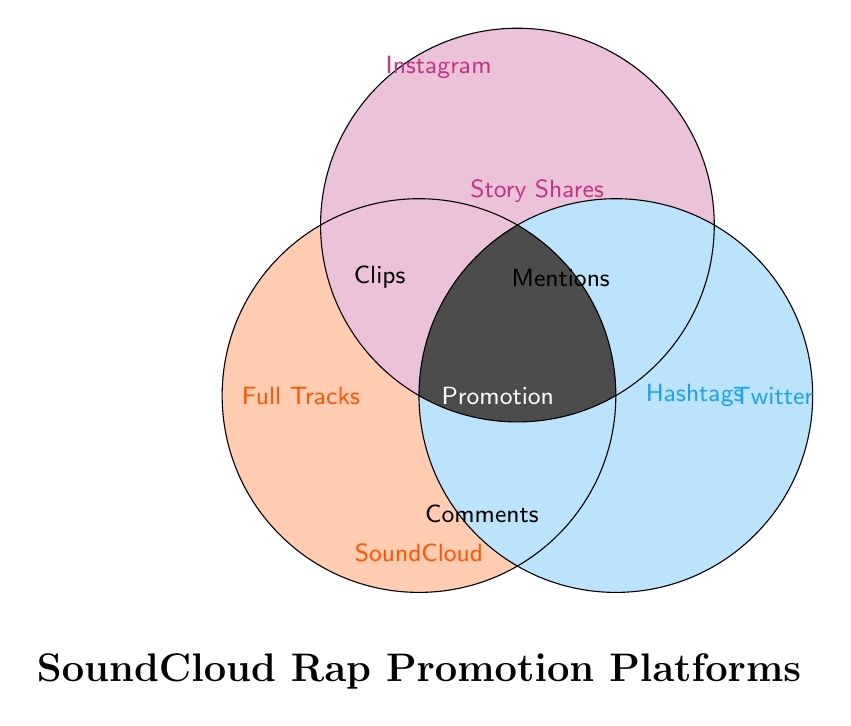What color represents SoundCloud? By looking at the Venn Diagram, the circle representing SoundCloud is filled with a distinct color. This color is closest to orange among the three used.
Answer: Orange Which platform is associated with Full Tracks? From the Venn Diagram, the text "Full Tracks" is located within the section labeled "SoundCloud." Therefore, SoundCloud is associated with Full Tracks.
Answer: SoundCloud Where do artists promote music using Story Shares? In the Venn Diagram, the term "Story Shares" is placed within the circle labeled "Instagram." Thus, artists promote music using Story Shares on Instagram.
Answer: Instagram How do fans interact with artists on Twitter based on the diagram? According to the Venn Diagram, "Mentions" are used for fan interaction within the Twitter circle.
Answer: Mentions Which area in the diagram suggests common methods of promotion across all platforms? The common area where all three platforms overlap contains the text "Promotion," indicating shared methods across SoundCloud, Instagram, and Twitter.
Answer: Promotion Which platform offers Hashtag Challenges for music promotion? The term "Hashtags" or "Hashtag Challenges" is placed in the section of the Venn Diagram corresponding to Twitter, indicating it's primarily used for this purpose.
Answer: Twitter What do the overlapping areas between SoundCloud and Instagram represent? The overlapping section between SoundCloud and Instagram circles includes the term "Clips," implying both platforms use short clips for promotion.
Answer: Clips Which feature is unique to only Instagram according to the Venn Diagram? The unique feature located entirely within the Instagram circle is "Story Shares," indicating it is specific to Instagram.
Answer: Story Shares How do users engage with content via comments based on the diagram? The term "Comments" is placed in the overlapping area between SoundCloud and Twitter but outside Instagram, suggesting this engagement method is used on both SoundCloud and Twitter.
Answer: SoundCloud and Twitter 